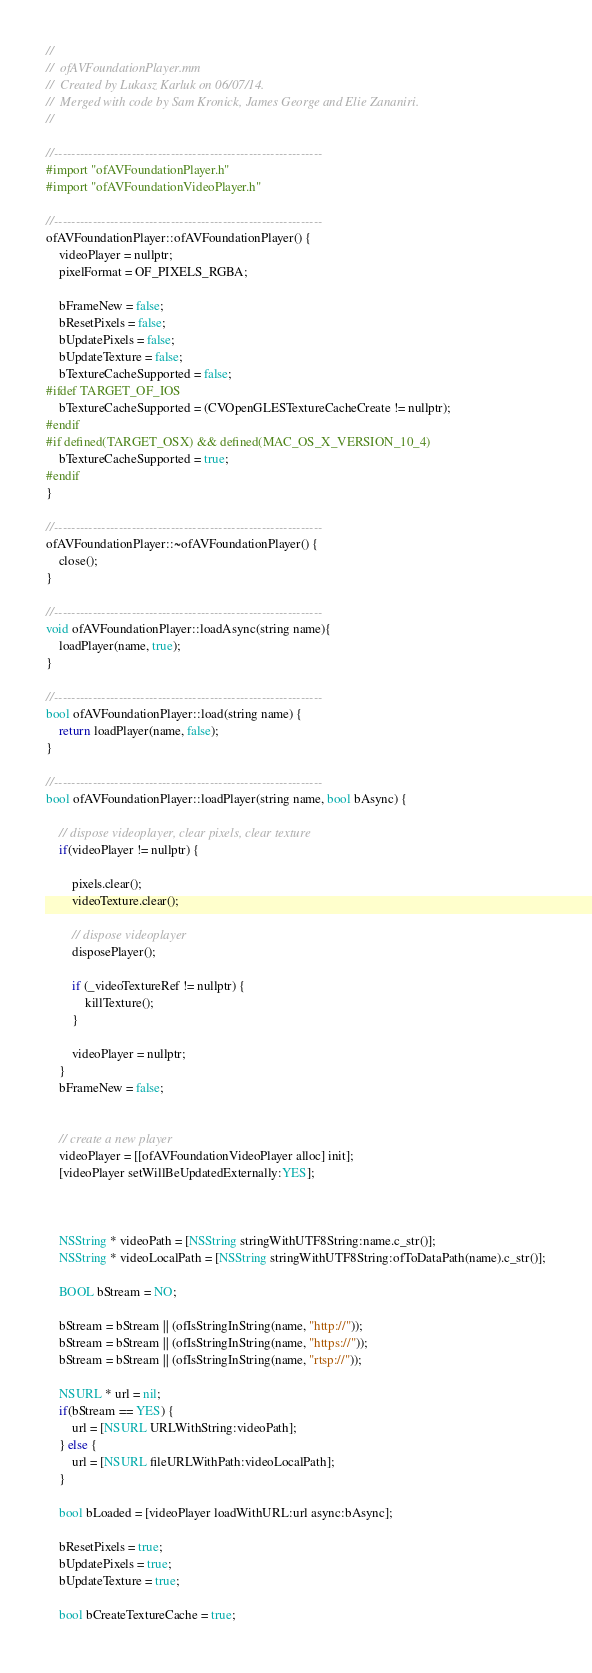<code> <loc_0><loc_0><loc_500><loc_500><_ObjectiveC_>//
//  ofAVFoundationPlayer.mm
//  Created by Lukasz Karluk on 06/07/14.
//	Merged with code by Sam Kronick, James George and Elie Zananiri.
//

//--------------------------------------------------------------
#import "ofAVFoundationPlayer.h"
#import "ofAVFoundationVideoPlayer.h"

//--------------------------------------------------------------
ofAVFoundationPlayer::ofAVFoundationPlayer() {
    videoPlayer = nullptr;
    pixelFormat = OF_PIXELS_RGBA;
	
    bFrameNew = false;
    bResetPixels = false;
    bUpdatePixels = false;
    bUpdateTexture = false;
    bTextureCacheSupported = false;
#ifdef TARGET_OF_IOS
    bTextureCacheSupported = (CVOpenGLESTextureCacheCreate != nullptr);
#endif
#if defined(TARGET_OSX) && defined(MAC_OS_X_VERSION_10_4)
	bTextureCacheSupported = true;
#endif
}

//--------------------------------------------------------------
ofAVFoundationPlayer::~ofAVFoundationPlayer() {
    close();
}

//--------------------------------------------------------------
void ofAVFoundationPlayer::loadAsync(string name){
    loadPlayer(name, true);
}

//--------------------------------------------------------------
bool ofAVFoundationPlayer::load(string name) {
    return loadPlayer(name, false);
}

//--------------------------------------------------------------
bool ofAVFoundationPlayer::loadPlayer(string name, bool bAsync) {

    // dispose videoplayer, clear pixels, clear texture
    if(videoPlayer != nullptr) {
        
        pixels.clear();
        videoTexture.clear();
        
        // dispose videoplayer
        disposePlayer();
        
        if (_videoTextureRef != nullptr) {
            killTexture();
        }
        
        videoPlayer = nullptr;
    }
    bFrameNew = false;

	
    // create a new player
    videoPlayer = [[ofAVFoundationVideoPlayer alloc] init];
    [videoPlayer setWillBeUpdatedExternally:YES];


	
    NSString * videoPath = [NSString stringWithUTF8String:name.c_str()];
    NSString * videoLocalPath = [NSString stringWithUTF8String:ofToDataPath(name).c_str()];

    BOOL bStream = NO;

    bStream = bStream || (ofIsStringInString(name, "http://"));
    bStream = bStream || (ofIsStringInString(name, "https://"));
    bStream = bStream || (ofIsStringInString(name, "rtsp://"));

    NSURL * url = nil;
    if(bStream == YES) {
        url = [NSURL URLWithString:videoPath];
    } else {
        url = [NSURL fileURLWithPath:videoLocalPath];
    }

    bool bLoaded = [videoPlayer loadWithURL:url async:bAsync];
	
    bResetPixels = true;
    bUpdatePixels = true;
    bUpdateTexture = true;

    bool bCreateTextureCache = true;</code> 